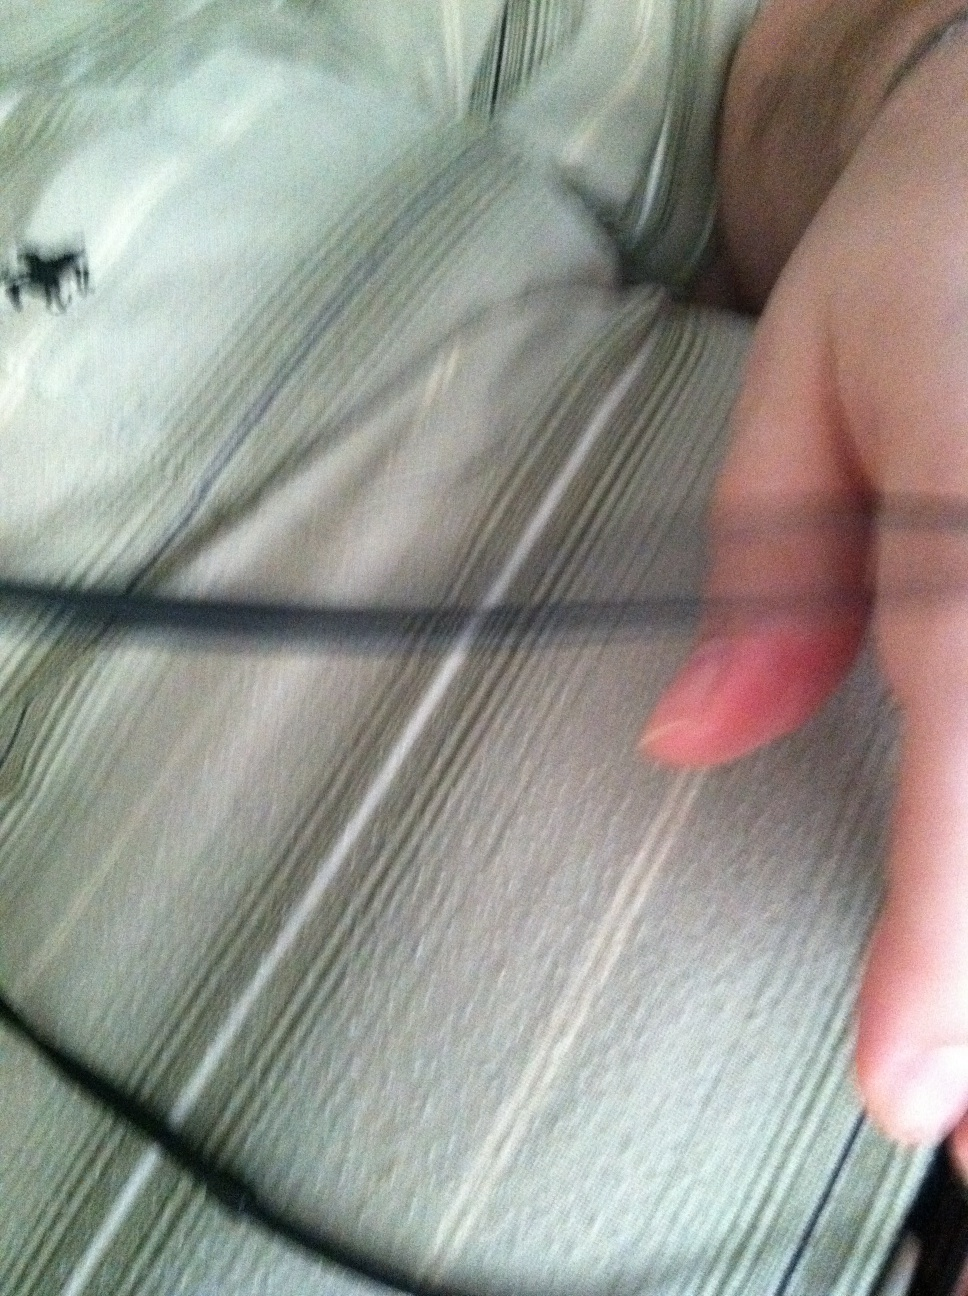Imagine I am wearing this shirt at a social gathering. How would others perceive it? At a social gathering, others might perceive your shirt as a blend of casual comfort and refined taste. The striped pattern suggests a well-considered choice, showing that you have a sense of style that is both approachable and sophisticated. 